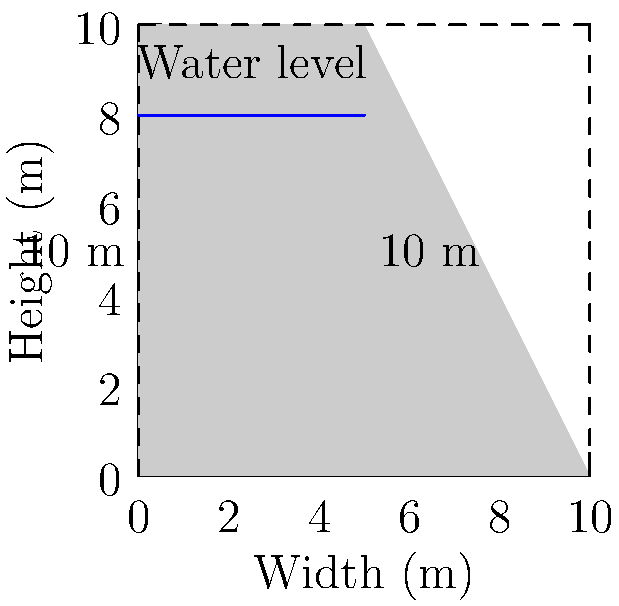Given the cross-sectional diagram of a concrete gravity dam, calculate the horizontal hydrostatic force acting on the dam when the water level is at 8 meters. Assume the density of water is 1000 kg/m³ and gravitational acceleration is 9.81 m/s². What measures would you recommend to ensure the long-term structural integrity of the dam? To calculate the horizontal hydrostatic force and assess the dam's structural integrity:

1. Determine the water pressure at the base of the dam:
   $P = \rho g h$
   Where $\rho$ = 1000 kg/m³, $g$ = 9.81 m/s², $h$ = 8 m
   $P = 1000 \times 9.81 \times 8 = 78,480$ Pa

2. Calculate the hydrostatic force:
   $F = \frac{1}{2} P h w$
   Where $w$ is the width of the dam (1 meter for unit calculation)
   $F = \frac{1}{2} \times 78,480 \times 8 \times 1 = 313,920$ N

3. Convert to kilonewtons:
   $F = 313.92$ kN

To ensure long-term structural integrity:

1. Regular inspections: Conduct visual and instrumental examinations to detect cracks, seepage, or deformations.
2. Monitoring: Install piezometers to measure water pressure within the dam and surrounding soil.
3. Seismic analysis: Perform periodic assessments of the dam's ability to withstand potential earthquakes.
4. Maintenance: Repair any detected issues promptly and maintain drainage systems.
5. Spillway capacity: Ensure adequate spillway capacity to handle extreme flood events.
6. Erosion control: Implement measures to prevent erosion at the dam's base and abutments.
7. Instrumentation: Install inclinometers and extensometers to monitor potential movements.
8. Periodic structural analysis: Conduct comprehensive structural analyses using modern computational methods.
Answer: Horizontal hydrostatic force: 313.92 kN. Recommendations: Regular inspections, monitoring, seismic analysis, maintenance, adequate spillway capacity, erosion control, instrumentation, and periodic structural analysis. 